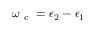<formula> <loc_0><loc_0><loc_500><loc_500>\omega _ { c } = \epsilon _ { 2 } - \epsilon _ { 1 }</formula> 